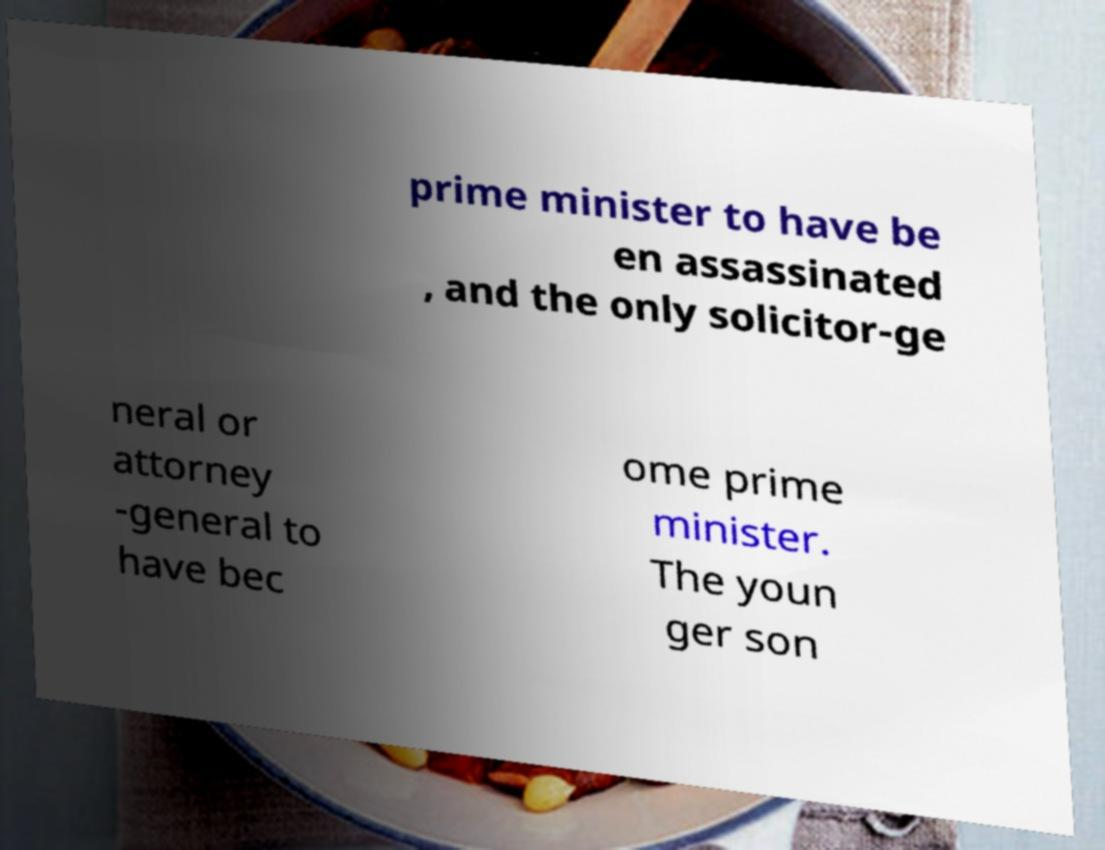Please identify and transcribe the text found in this image. prime minister to have be en assassinated , and the only solicitor-ge neral or attorney -general to have bec ome prime minister. The youn ger son 